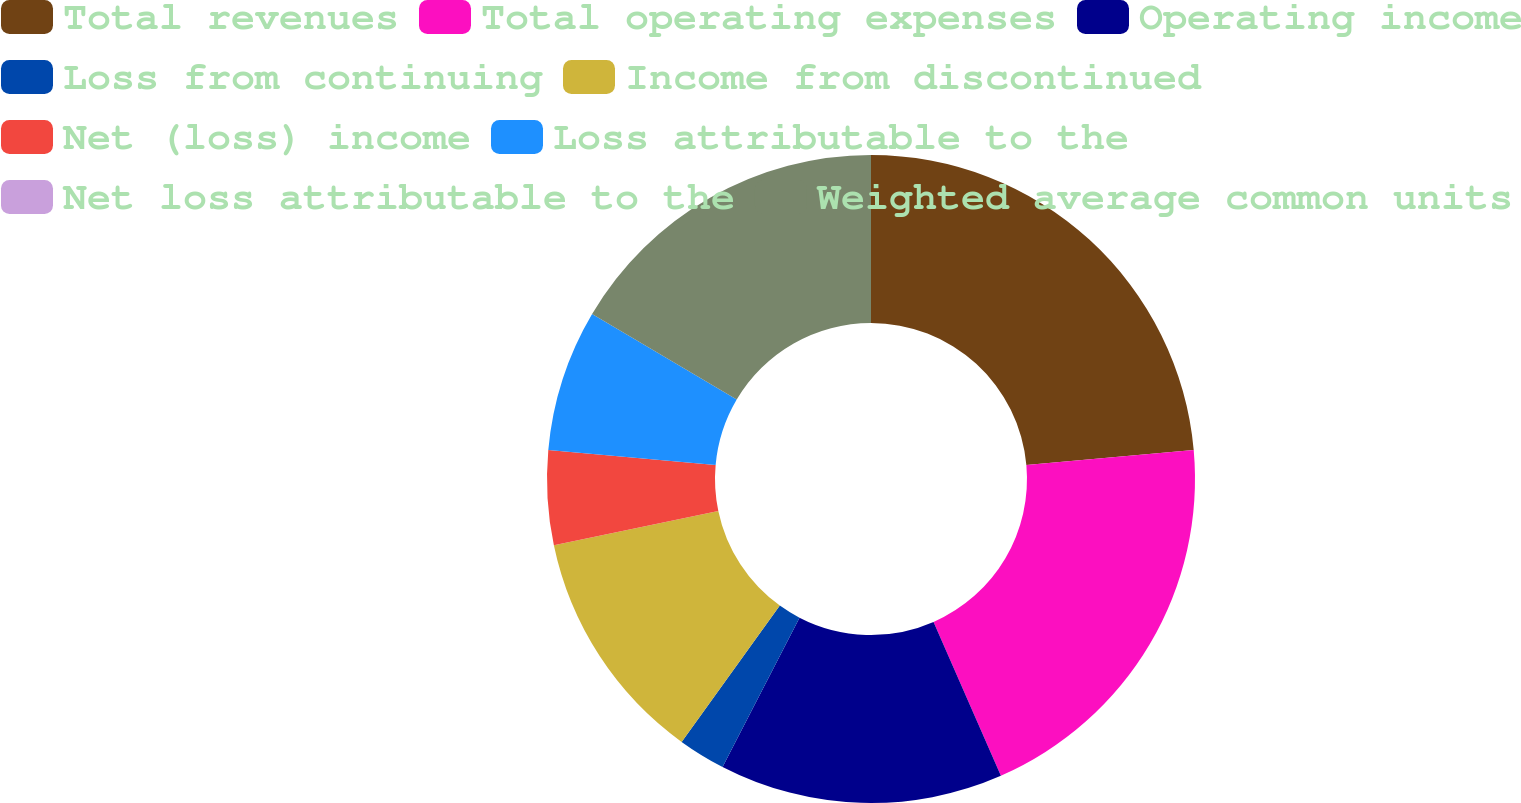Convert chart. <chart><loc_0><loc_0><loc_500><loc_500><pie_chart><fcel>Total revenues<fcel>Total operating expenses<fcel>Operating income<fcel>Loss from continuing<fcel>Income from discontinued<fcel>Net (loss) income<fcel>Loss attributable to the<fcel>Net loss attributable to the<fcel>Weighted average common units<nl><fcel>23.57%<fcel>19.86%<fcel>14.14%<fcel>2.36%<fcel>11.78%<fcel>4.71%<fcel>7.07%<fcel>0.0%<fcel>16.5%<nl></chart> 